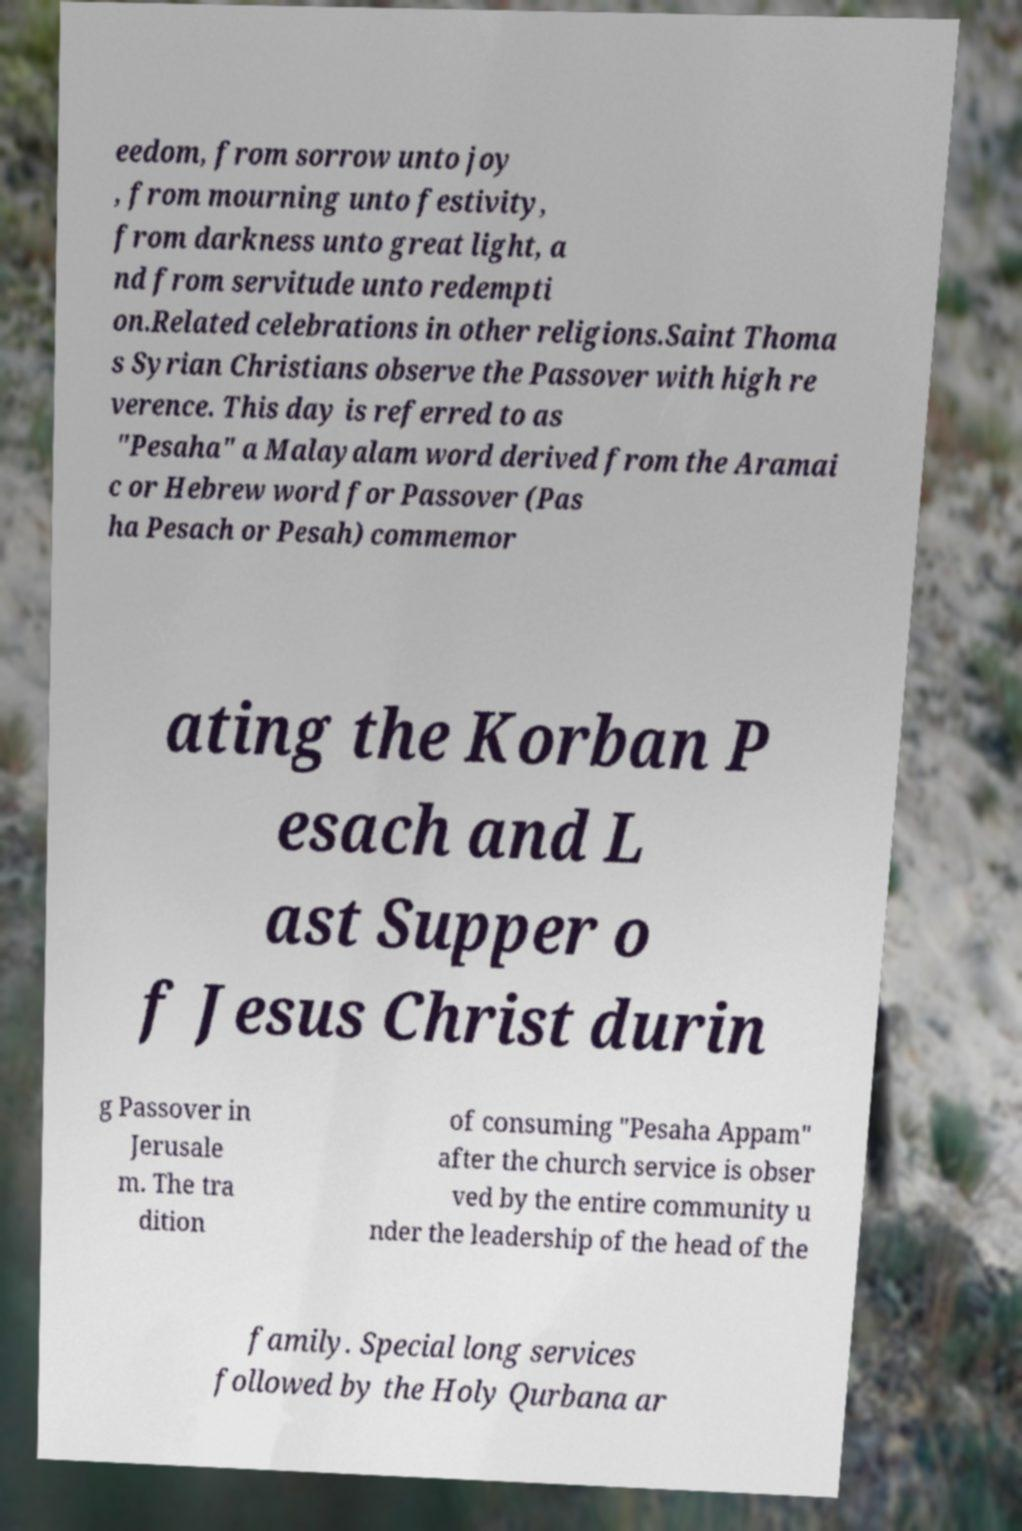What messages or text are displayed in this image? I need them in a readable, typed format. eedom, from sorrow unto joy , from mourning unto festivity, from darkness unto great light, a nd from servitude unto redempti on.Related celebrations in other religions.Saint Thoma s Syrian Christians observe the Passover with high re verence. This day is referred to as "Pesaha" a Malayalam word derived from the Aramai c or Hebrew word for Passover (Pas ha Pesach or Pesah) commemor ating the Korban P esach and L ast Supper o f Jesus Christ durin g Passover in Jerusale m. The tra dition of consuming "Pesaha Appam" after the church service is obser ved by the entire community u nder the leadership of the head of the family. Special long services followed by the Holy Qurbana ar 